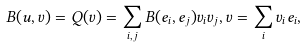Convert formula to latex. <formula><loc_0><loc_0><loc_500><loc_500>B ( u , v ) = Q ( v ) = \sum _ { i , j } B ( e _ { i } , e _ { j } ) v _ { i } v _ { j } , v = \sum _ { i } v _ { i } e _ { i } ,</formula> 